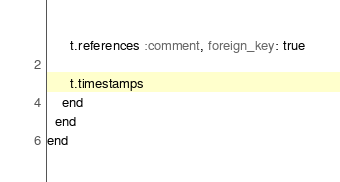<code> <loc_0><loc_0><loc_500><loc_500><_Ruby_>      t.references :comment, foreign_key: true

      t.timestamps
    end
  end
end
</code> 